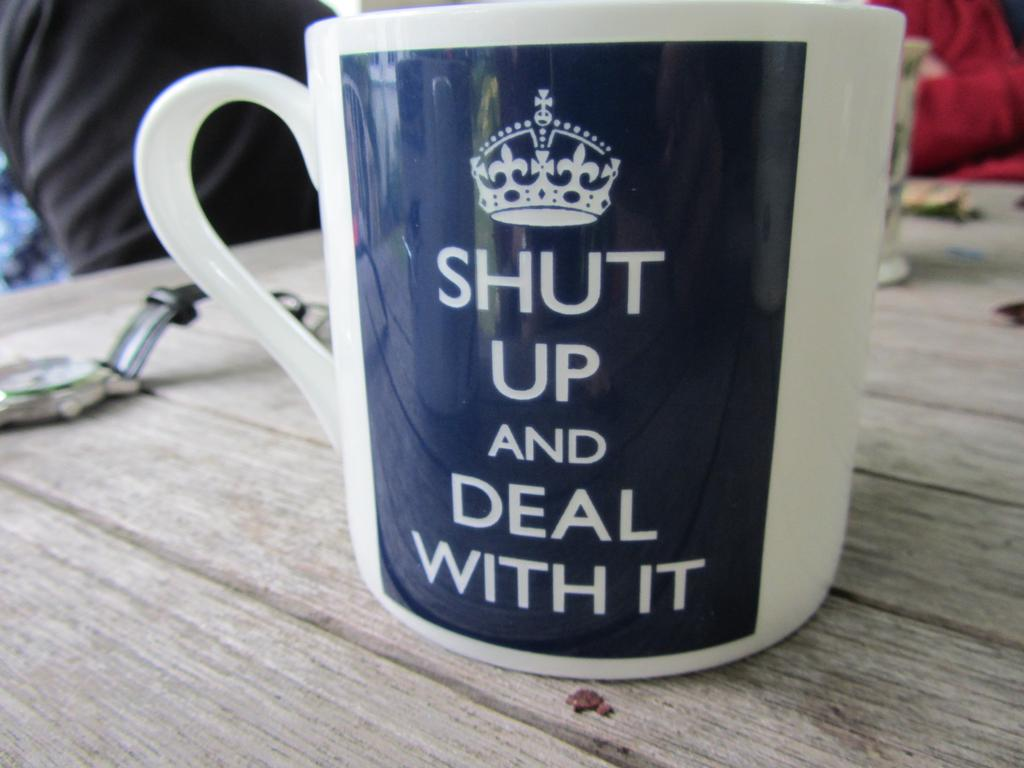What is written or depicted on the cup in the image? There is a cup with a quotation and a logo in the image. What type of accessory can be seen in the image? There is a watch in the image. What other objects are present on the table in the image? There are other objects on the table in the image. How many ants are crawling on the watch in the image? There are no ants present in the image. What type of pig is depicted on the cup in the image? There is no pig depicted on the cup in the image; it has a quotation and a logo. 